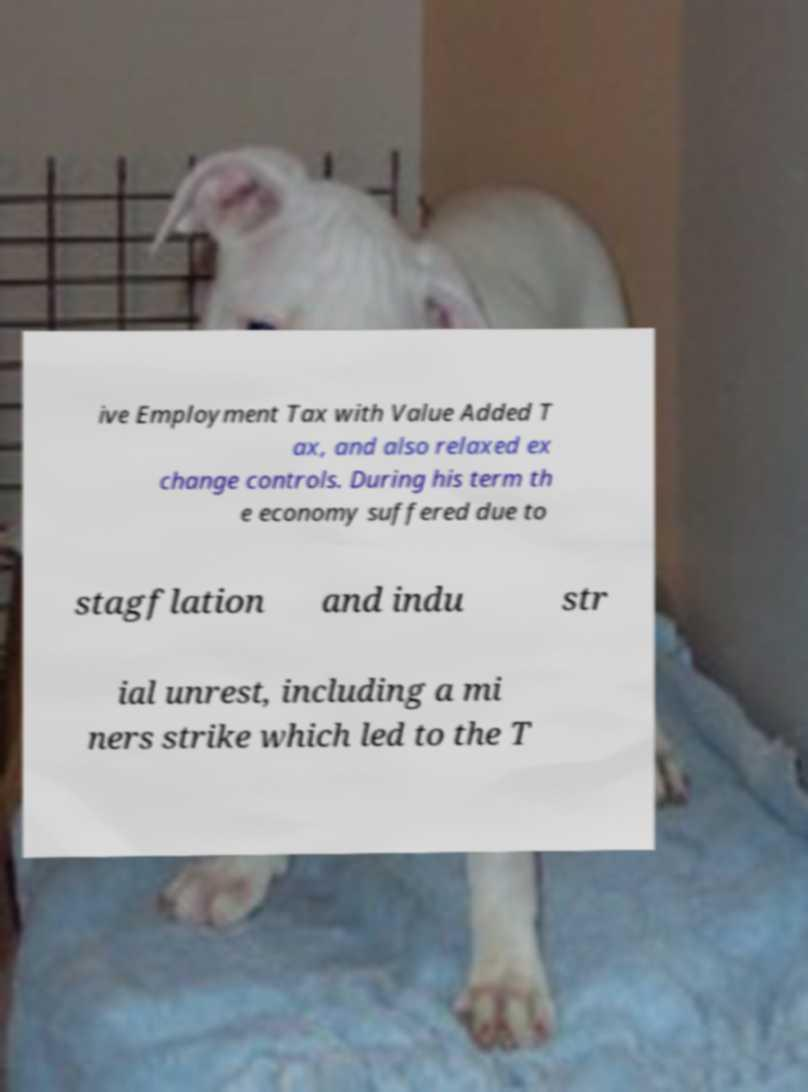I need the written content from this picture converted into text. Can you do that? ive Employment Tax with Value Added T ax, and also relaxed ex change controls. During his term th e economy suffered due to stagflation and indu str ial unrest, including a mi ners strike which led to the T 